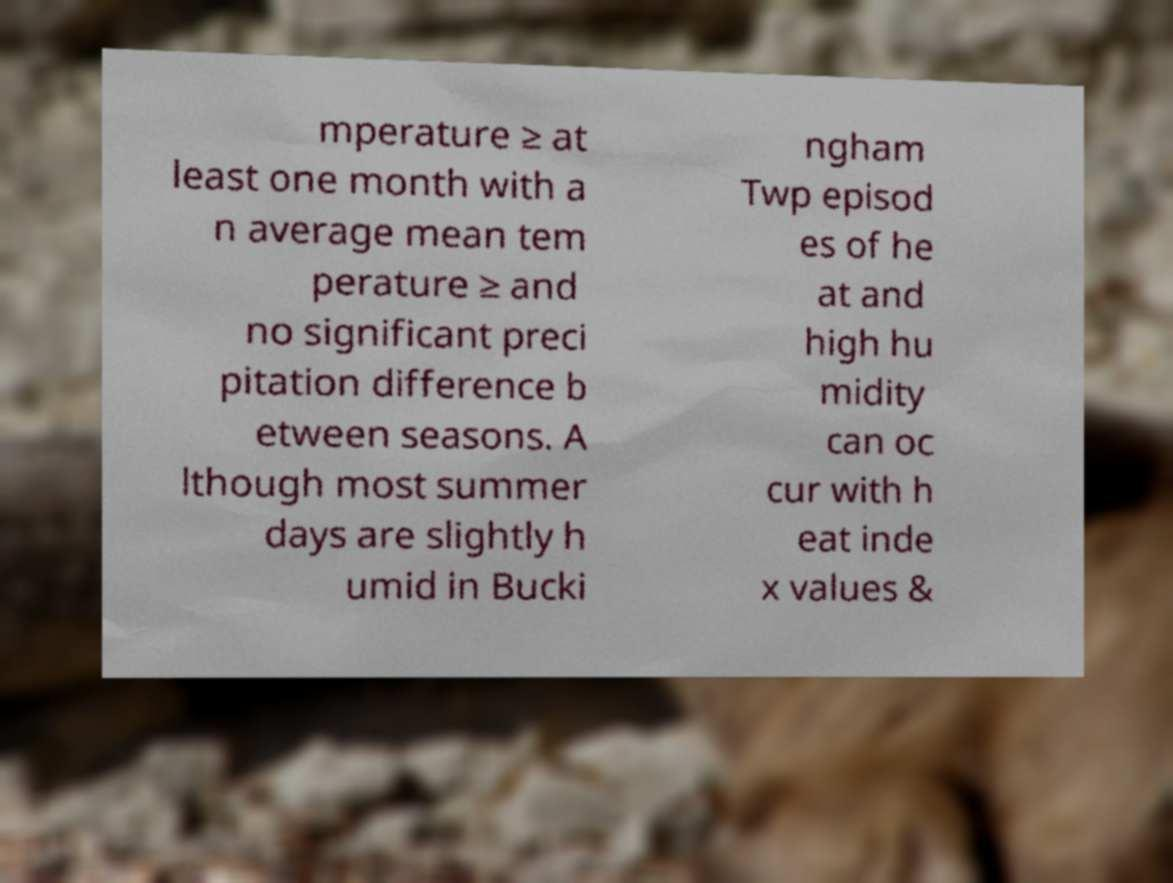There's text embedded in this image that I need extracted. Can you transcribe it verbatim? mperature ≥ at least one month with a n average mean tem perature ≥ and no significant preci pitation difference b etween seasons. A lthough most summer days are slightly h umid in Bucki ngham Twp episod es of he at and high hu midity can oc cur with h eat inde x values & 